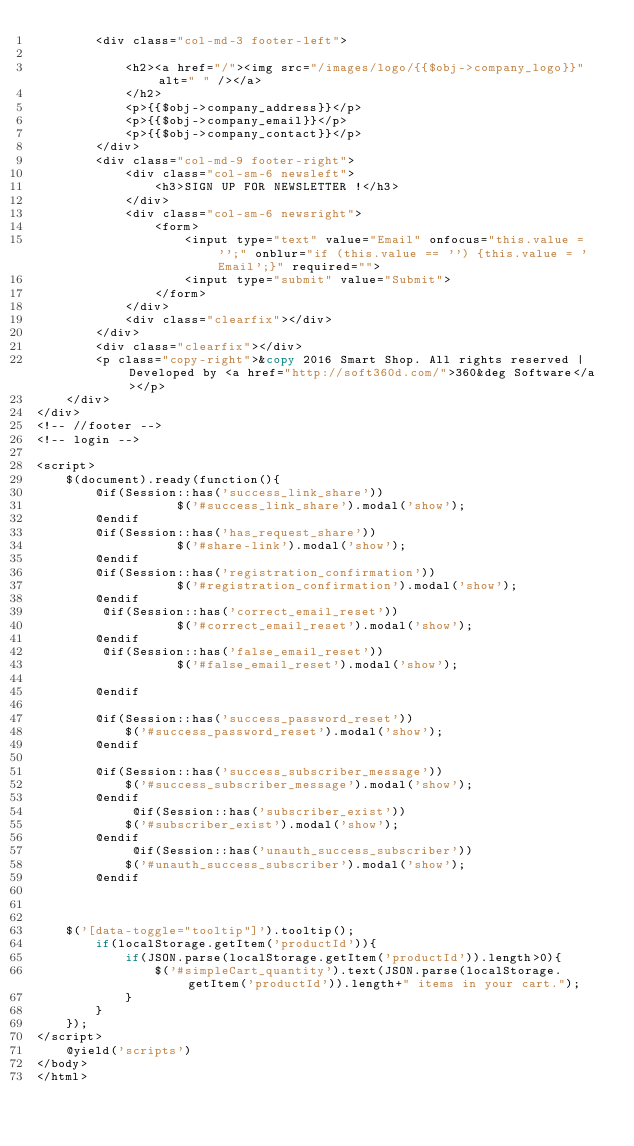<code> <loc_0><loc_0><loc_500><loc_500><_PHP_>        <div class="col-md-3 footer-left">

            <h2><a href="/"><img src="/images/logo/{{$obj->company_logo}}" alt=" " /></a>
            </h2>
            <p>{{$obj->company_address}}</p>
            <p>{{$obj->company_email}}</p>
            <p>{{$obj->company_contact}}</p>
        </div>
        <div class="col-md-9 footer-right">
            <div class="col-sm-6 newsleft">
                <h3>SIGN UP FOR NEWSLETTER !</h3>
            </div>
            <div class="col-sm-6 newsright">
                <form>
                    <input type="text" value="Email" onfocus="this.value = '';" onblur="if (this.value == '') {this.value = 'Email';}" required="">
                    <input type="submit" value="Submit">
                </form>
            </div>
            <div class="clearfix"></div>
        </div>
        <div class="clearfix"></div>
        <p class="copy-right">&copy 2016 Smart Shop. All rights reserved | Developed by <a href="http://soft360d.com/">360&deg Software</a></p>
    </div>
</div>
<!-- //footer -->
<!-- login -->

<script>
    $(document).ready(function(){
        @if(Session::has('success_link_share'))
                   $('#success_link_share').modal('show');
        @endif
        @if(Session::has('has_request_share'))
                   $('#share-link').modal('show');
        @endif
        @if(Session::has('registration_confirmation'))
                   $('#registration_confirmation').modal('show');
        @endif
         @if(Session::has('correct_email_reset'))
                   $('#correct_email_reset').modal('show');
        @endif
         @if(Session::has('false_email_reset'))
                   $('#false_email_reset').modal('show');

        @endif

        @if(Session::has('success_password_reset'))
            $('#success_password_reset').modal('show');
        @endif

        @if(Session::has('success_subscriber_message'))
            $('#success_subscriber_message').modal('show');
        @endif
             @if(Session::has('subscriber_exist'))
            $('#subscriber_exist').modal('show');
        @endif
             @if(Session::has('unauth_success_subscriber'))
            $('#unauth_success_subscriber').modal('show');
        @endif



    $('[data-toggle="tooltip"]').tooltip();
        if(localStorage.getItem('productId')){
            if(JSON.parse(localStorage.getItem('productId')).length>0){
                $('#simpleCart_quantity').text(JSON.parse(localStorage.getItem('productId')).length+" items in your cart.");
            }
        }
    });
</script>
    @yield('scripts')
</body>
</html>
</code> 